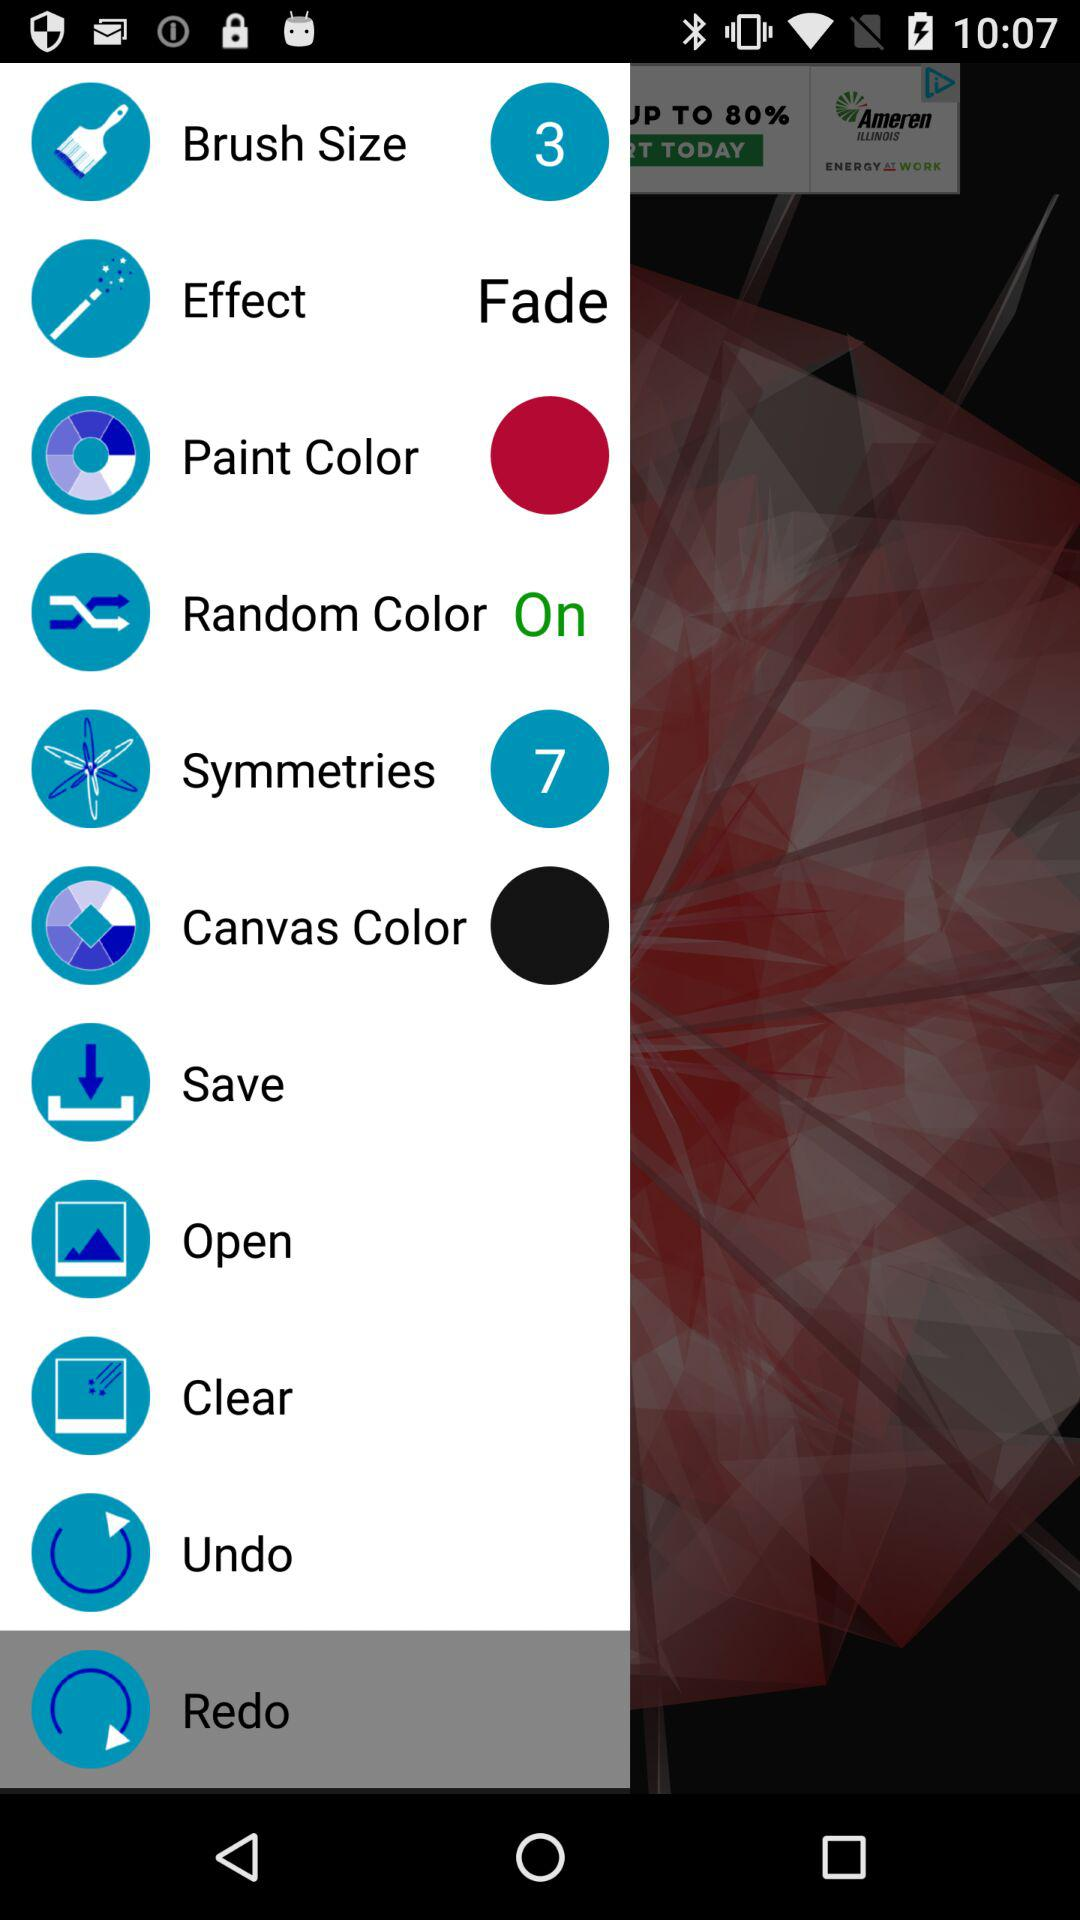What is the brush size? The brush size is 3. 